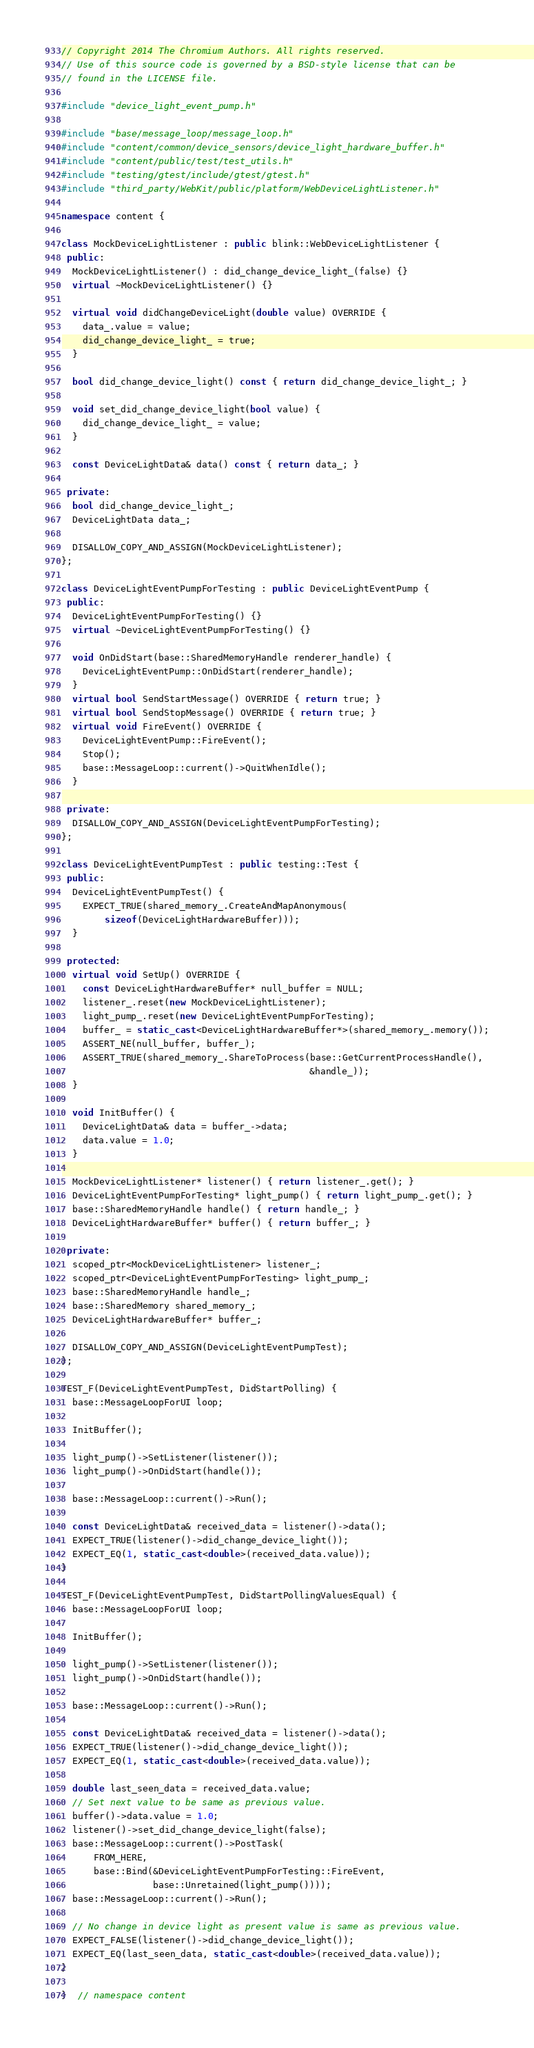<code> <loc_0><loc_0><loc_500><loc_500><_C++_>// Copyright 2014 The Chromium Authors. All rights reserved.
// Use of this source code is governed by a BSD-style license that can be
// found in the LICENSE file.

#include "device_light_event_pump.h"

#include "base/message_loop/message_loop.h"
#include "content/common/device_sensors/device_light_hardware_buffer.h"
#include "content/public/test/test_utils.h"
#include "testing/gtest/include/gtest/gtest.h"
#include "third_party/WebKit/public/platform/WebDeviceLightListener.h"

namespace content {

class MockDeviceLightListener : public blink::WebDeviceLightListener {
 public:
  MockDeviceLightListener() : did_change_device_light_(false) {}
  virtual ~MockDeviceLightListener() {}

  virtual void didChangeDeviceLight(double value) OVERRIDE {
    data_.value = value;
    did_change_device_light_ = true;
  }

  bool did_change_device_light() const { return did_change_device_light_; }

  void set_did_change_device_light(bool value) {
    did_change_device_light_ = value;
  }

  const DeviceLightData& data() const { return data_; }

 private:
  bool did_change_device_light_;
  DeviceLightData data_;

  DISALLOW_COPY_AND_ASSIGN(MockDeviceLightListener);
};

class DeviceLightEventPumpForTesting : public DeviceLightEventPump {
 public:
  DeviceLightEventPumpForTesting() {}
  virtual ~DeviceLightEventPumpForTesting() {}

  void OnDidStart(base::SharedMemoryHandle renderer_handle) {
    DeviceLightEventPump::OnDidStart(renderer_handle);
  }
  virtual bool SendStartMessage() OVERRIDE { return true; }
  virtual bool SendStopMessage() OVERRIDE { return true; }
  virtual void FireEvent() OVERRIDE {
    DeviceLightEventPump::FireEvent();
    Stop();
    base::MessageLoop::current()->QuitWhenIdle();
  }

 private:
  DISALLOW_COPY_AND_ASSIGN(DeviceLightEventPumpForTesting);
};

class DeviceLightEventPumpTest : public testing::Test {
 public:
  DeviceLightEventPumpTest() {
    EXPECT_TRUE(shared_memory_.CreateAndMapAnonymous(
        sizeof(DeviceLightHardwareBuffer)));
  }

 protected:
  virtual void SetUp() OVERRIDE {
    const DeviceLightHardwareBuffer* null_buffer = NULL;
    listener_.reset(new MockDeviceLightListener);
    light_pump_.reset(new DeviceLightEventPumpForTesting);
    buffer_ = static_cast<DeviceLightHardwareBuffer*>(shared_memory_.memory());
    ASSERT_NE(null_buffer, buffer_);
    ASSERT_TRUE(shared_memory_.ShareToProcess(base::GetCurrentProcessHandle(),
                                              &handle_));
  }

  void InitBuffer() {
    DeviceLightData& data = buffer_->data;
    data.value = 1.0;
  }

  MockDeviceLightListener* listener() { return listener_.get(); }
  DeviceLightEventPumpForTesting* light_pump() { return light_pump_.get(); }
  base::SharedMemoryHandle handle() { return handle_; }
  DeviceLightHardwareBuffer* buffer() { return buffer_; }

 private:
  scoped_ptr<MockDeviceLightListener> listener_;
  scoped_ptr<DeviceLightEventPumpForTesting> light_pump_;
  base::SharedMemoryHandle handle_;
  base::SharedMemory shared_memory_;
  DeviceLightHardwareBuffer* buffer_;

  DISALLOW_COPY_AND_ASSIGN(DeviceLightEventPumpTest);
};

TEST_F(DeviceLightEventPumpTest, DidStartPolling) {
  base::MessageLoopForUI loop;

  InitBuffer();

  light_pump()->SetListener(listener());
  light_pump()->OnDidStart(handle());

  base::MessageLoop::current()->Run();

  const DeviceLightData& received_data = listener()->data();
  EXPECT_TRUE(listener()->did_change_device_light());
  EXPECT_EQ(1, static_cast<double>(received_data.value));
}

TEST_F(DeviceLightEventPumpTest, DidStartPollingValuesEqual) {
  base::MessageLoopForUI loop;

  InitBuffer();

  light_pump()->SetListener(listener());
  light_pump()->OnDidStart(handle());

  base::MessageLoop::current()->Run();

  const DeviceLightData& received_data = listener()->data();
  EXPECT_TRUE(listener()->did_change_device_light());
  EXPECT_EQ(1, static_cast<double>(received_data.value));

  double last_seen_data = received_data.value;
  // Set next value to be same as previous value.
  buffer()->data.value = 1.0;
  listener()->set_did_change_device_light(false);
  base::MessageLoop::current()->PostTask(
      FROM_HERE,
      base::Bind(&DeviceLightEventPumpForTesting::FireEvent,
                 base::Unretained(light_pump())));
  base::MessageLoop::current()->Run();

  // No change in device light as present value is same as previous value.
  EXPECT_FALSE(listener()->did_change_device_light());
  EXPECT_EQ(last_seen_data, static_cast<double>(received_data.value));
}

}  // namespace content
</code> 